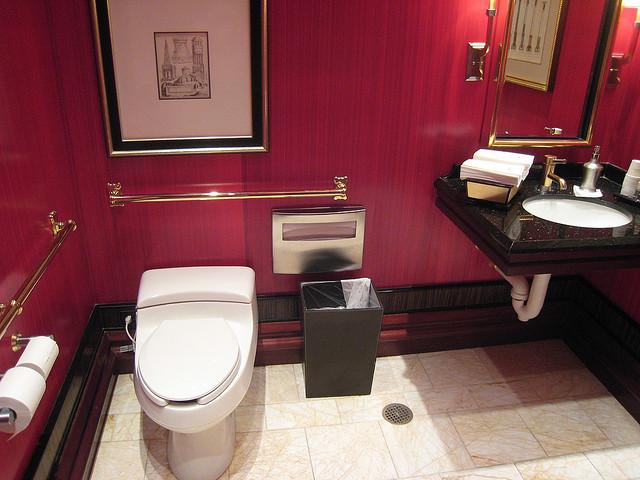Is there a bag in the trash can?
Give a very brief answer. Yes. How many rolls of toilet paper are visible?
Keep it brief. 2. Is this bathroom red?
Give a very brief answer. Yes. 